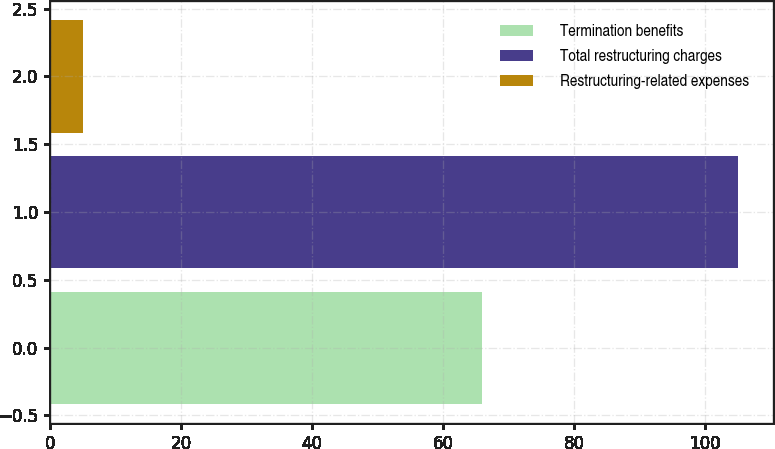Convert chart to OTSL. <chart><loc_0><loc_0><loc_500><loc_500><bar_chart><fcel>Termination benefits<fcel>Total restructuring charges<fcel>Restructuring-related expenses<nl><fcel>66<fcel>105<fcel>5<nl></chart> 